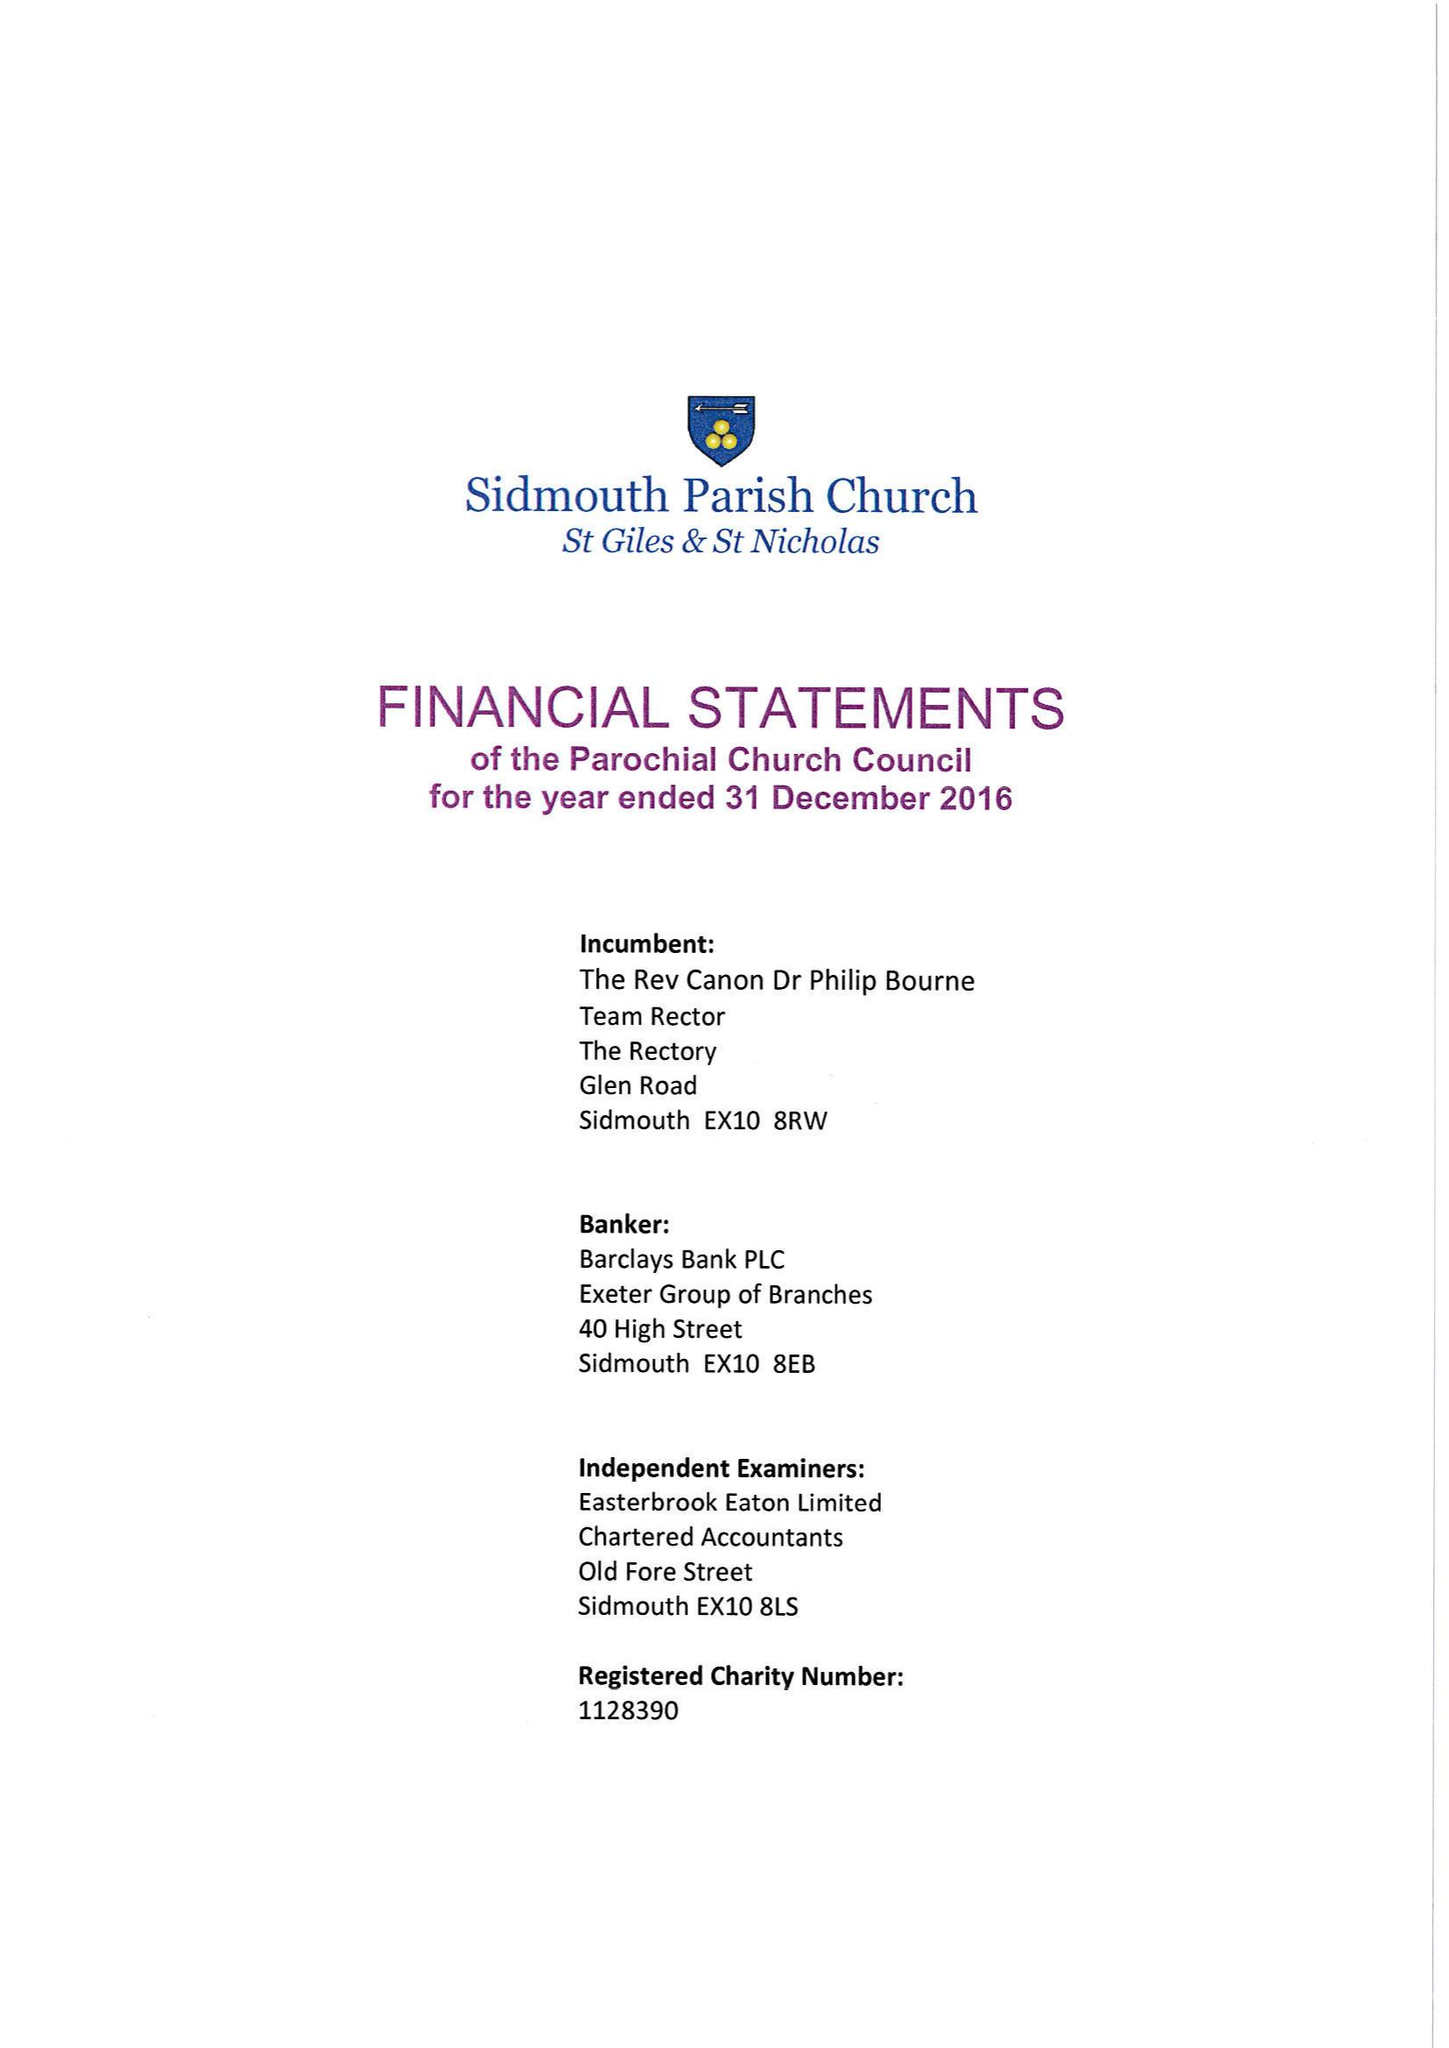What is the value for the address__street_line?
Answer the question using a single word or phrase. HIGHER BROAD OAK ROAD 